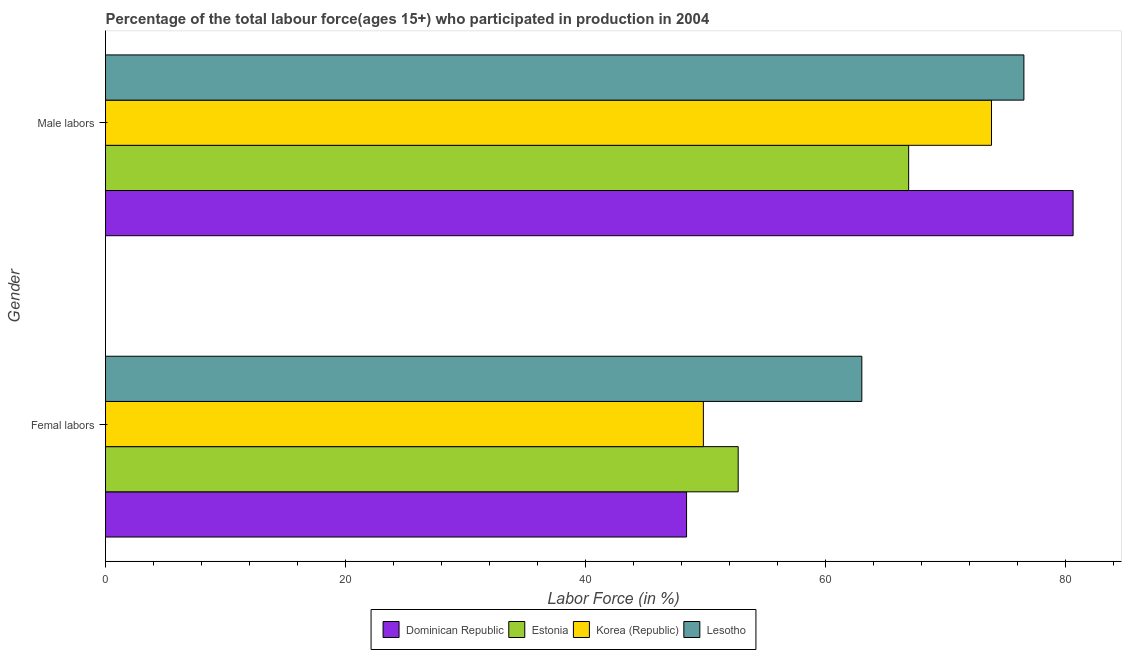How many different coloured bars are there?
Provide a succinct answer. 4. How many groups of bars are there?
Offer a terse response. 2. Are the number of bars per tick equal to the number of legend labels?
Provide a succinct answer. Yes. How many bars are there on the 1st tick from the top?
Keep it short and to the point. 4. What is the label of the 1st group of bars from the top?
Provide a short and direct response. Male labors. What is the percentage of female labor force in Korea (Republic)?
Provide a short and direct response. 49.8. Across all countries, what is the minimum percentage of male labour force?
Offer a very short reply. 66.9. In which country was the percentage of female labor force maximum?
Your answer should be very brief. Lesotho. In which country was the percentage of female labor force minimum?
Offer a very short reply. Dominican Republic. What is the total percentage of female labor force in the graph?
Keep it short and to the point. 213.9. What is the difference between the percentage of male labour force in Lesotho and that in Estonia?
Ensure brevity in your answer.  9.6. What is the difference between the percentage of male labour force in Dominican Republic and the percentage of female labor force in Estonia?
Ensure brevity in your answer.  27.9. What is the average percentage of male labour force per country?
Provide a short and direct response. 74.45. What is the difference between the percentage of female labor force and percentage of male labour force in Korea (Republic)?
Keep it short and to the point. -24. In how many countries, is the percentage of female labor force greater than 64 %?
Make the answer very short. 0. What is the ratio of the percentage of male labour force in Dominican Republic to that in Korea (Republic)?
Provide a succinct answer. 1.09. In how many countries, is the percentage of male labour force greater than the average percentage of male labour force taken over all countries?
Make the answer very short. 2. What does the 1st bar from the bottom in Male labors represents?
Provide a short and direct response. Dominican Republic. How many bars are there?
Offer a terse response. 8. Does the graph contain any zero values?
Ensure brevity in your answer.  No. Where does the legend appear in the graph?
Keep it short and to the point. Bottom center. How are the legend labels stacked?
Offer a very short reply. Horizontal. What is the title of the graph?
Provide a succinct answer. Percentage of the total labour force(ages 15+) who participated in production in 2004. Does "Finland" appear as one of the legend labels in the graph?
Provide a succinct answer. No. What is the label or title of the X-axis?
Your answer should be compact. Labor Force (in %). What is the Labor Force (in %) of Dominican Republic in Femal labors?
Keep it short and to the point. 48.4. What is the Labor Force (in %) in Estonia in Femal labors?
Give a very brief answer. 52.7. What is the Labor Force (in %) of Korea (Republic) in Femal labors?
Provide a short and direct response. 49.8. What is the Labor Force (in %) of Dominican Republic in Male labors?
Your answer should be very brief. 80.6. What is the Labor Force (in %) in Estonia in Male labors?
Your response must be concise. 66.9. What is the Labor Force (in %) in Korea (Republic) in Male labors?
Your answer should be very brief. 73.8. What is the Labor Force (in %) in Lesotho in Male labors?
Provide a succinct answer. 76.5. Across all Gender, what is the maximum Labor Force (in %) in Dominican Republic?
Provide a short and direct response. 80.6. Across all Gender, what is the maximum Labor Force (in %) in Estonia?
Ensure brevity in your answer.  66.9. Across all Gender, what is the maximum Labor Force (in %) in Korea (Republic)?
Offer a very short reply. 73.8. Across all Gender, what is the maximum Labor Force (in %) of Lesotho?
Give a very brief answer. 76.5. Across all Gender, what is the minimum Labor Force (in %) of Dominican Republic?
Your answer should be compact. 48.4. Across all Gender, what is the minimum Labor Force (in %) of Estonia?
Give a very brief answer. 52.7. Across all Gender, what is the minimum Labor Force (in %) of Korea (Republic)?
Give a very brief answer. 49.8. What is the total Labor Force (in %) in Dominican Republic in the graph?
Make the answer very short. 129. What is the total Labor Force (in %) in Estonia in the graph?
Your response must be concise. 119.6. What is the total Labor Force (in %) in Korea (Republic) in the graph?
Offer a very short reply. 123.6. What is the total Labor Force (in %) in Lesotho in the graph?
Offer a terse response. 139.5. What is the difference between the Labor Force (in %) in Dominican Republic in Femal labors and that in Male labors?
Your answer should be very brief. -32.2. What is the difference between the Labor Force (in %) in Estonia in Femal labors and that in Male labors?
Offer a terse response. -14.2. What is the difference between the Labor Force (in %) of Korea (Republic) in Femal labors and that in Male labors?
Keep it short and to the point. -24. What is the difference between the Labor Force (in %) in Dominican Republic in Femal labors and the Labor Force (in %) in Estonia in Male labors?
Make the answer very short. -18.5. What is the difference between the Labor Force (in %) of Dominican Republic in Femal labors and the Labor Force (in %) of Korea (Republic) in Male labors?
Give a very brief answer. -25.4. What is the difference between the Labor Force (in %) in Dominican Republic in Femal labors and the Labor Force (in %) in Lesotho in Male labors?
Your answer should be compact. -28.1. What is the difference between the Labor Force (in %) of Estonia in Femal labors and the Labor Force (in %) of Korea (Republic) in Male labors?
Keep it short and to the point. -21.1. What is the difference between the Labor Force (in %) in Estonia in Femal labors and the Labor Force (in %) in Lesotho in Male labors?
Make the answer very short. -23.8. What is the difference between the Labor Force (in %) of Korea (Republic) in Femal labors and the Labor Force (in %) of Lesotho in Male labors?
Provide a succinct answer. -26.7. What is the average Labor Force (in %) in Dominican Republic per Gender?
Your answer should be compact. 64.5. What is the average Labor Force (in %) of Estonia per Gender?
Offer a terse response. 59.8. What is the average Labor Force (in %) in Korea (Republic) per Gender?
Make the answer very short. 61.8. What is the average Labor Force (in %) of Lesotho per Gender?
Give a very brief answer. 69.75. What is the difference between the Labor Force (in %) of Dominican Republic and Labor Force (in %) of Estonia in Femal labors?
Your answer should be compact. -4.3. What is the difference between the Labor Force (in %) of Dominican Republic and Labor Force (in %) of Korea (Republic) in Femal labors?
Provide a short and direct response. -1.4. What is the difference between the Labor Force (in %) of Dominican Republic and Labor Force (in %) of Lesotho in Femal labors?
Provide a short and direct response. -14.6. What is the difference between the Labor Force (in %) in Estonia and Labor Force (in %) in Korea (Republic) in Femal labors?
Provide a succinct answer. 2.9. What is the difference between the Labor Force (in %) of Dominican Republic and Labor Force (in %) of Estonia in Male labors?
Keep it short and to the point. 13.7. What is the difference between the Labor Force (in %) of Dominican Republic and Labor Force (in %) of Korea (Republic) in Male labors?
Your answer should be compact. 6.8. What is the difference between the Labor Force (in %) in Dominican Republic and Labor Force (in %) in Lesotho in Male labors?
Offer a terse response. 4.1. What is the difference between the Labor Force (in %) in Estonia and Labor Force (in %) in Lesotho in Male labors?
Ensure brevity in your answer.  -9.6. What is the ratio of the Labor Force (in %) of Dominican Republic in Femal labors to that in Male labors?
Your response must be concise. 0.6. What is the ratio of the Labor Force (in %) of Estonia in Femal labors to that in Male labors?
Your response must be concise. 0.79. What is the ratio of the Labor Force (in %) of Korea (Republic) in Femal labors to that in Male labors?
Provide a short and direct response. 0.67. What is the ratio of the Labor Force (in %) in Lesotho in Femal labors to that in Male labors?
Ensure brevity in your answer.  0.82. What is the difference between the highest and the second highest Labor Force (in %) in Dominican Republic?
Offer a very short reply. 32.2. What is the difference between the highest and the lowest Labor Force (in %) of Dominican Republic?
Your answer should be compact. 32.2. What is the difference between the highest and the lowest Labor Force (in %) of Korea (Republic)?
Your response must be concise. 24. What is the difference between the highest and the lowest Labor Force (in %) in Lesotho?
Your response must be concise. 13.5. 